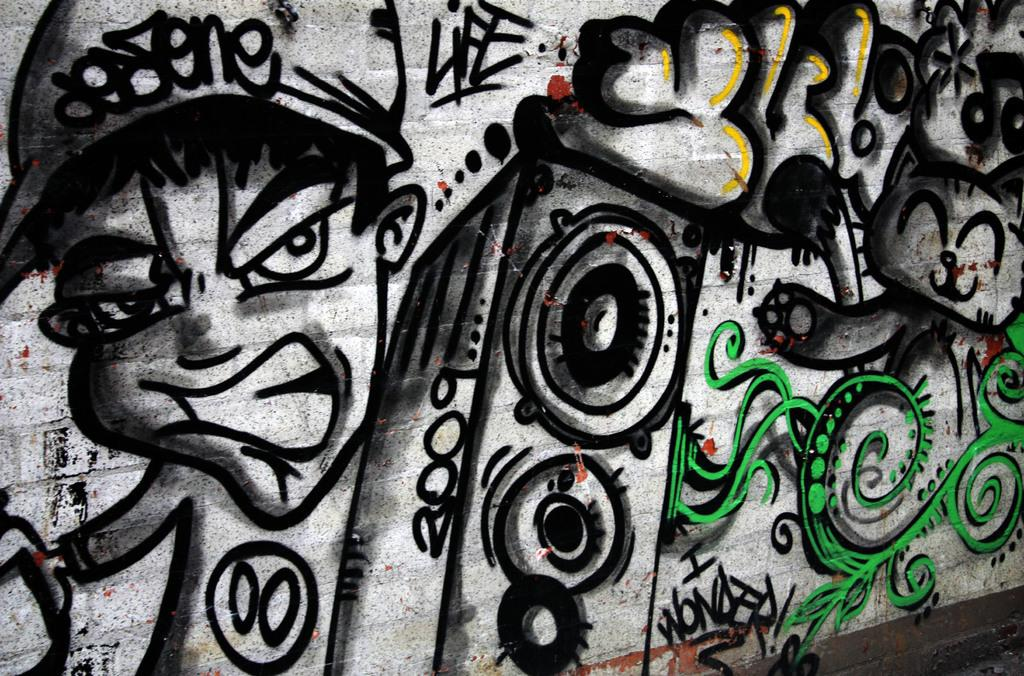What is depicted on the wall in the image? There is a drawing of a boy on the wall. Can you describe the drawing in more detail? Unfortunately, the facts provided do not give any additional details about the drawing. Is there anything else on the wall besides the drawing? The facts provided do not mention any other objects or features on the wall. What type of letter is the boy holding in the drawing? There is no letter present in the drawing; it only depicts a boy. Is there a feast happening in the background of the drawing? The facts provided do not mention any background elements or additional details about the drawing. 